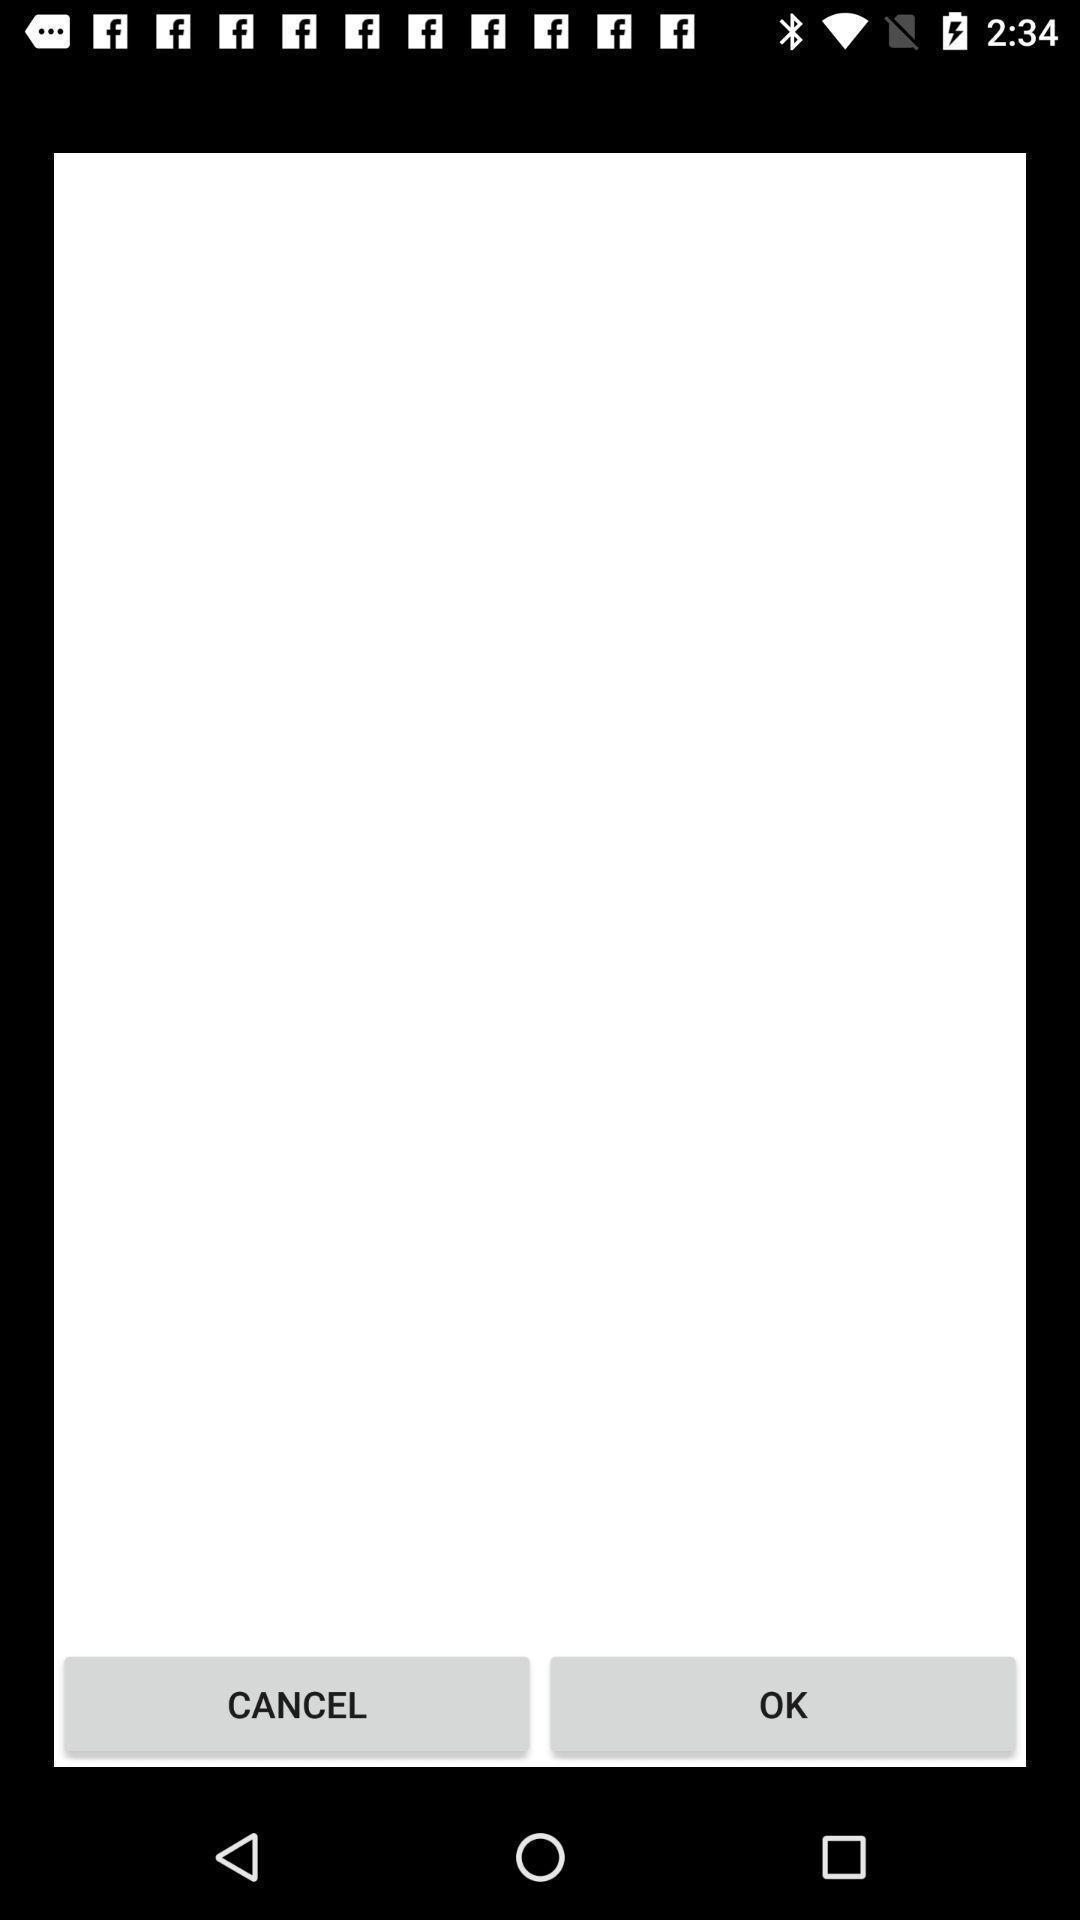Describe the visual elements of this screenshot. Screen shows cancel and ok option. 